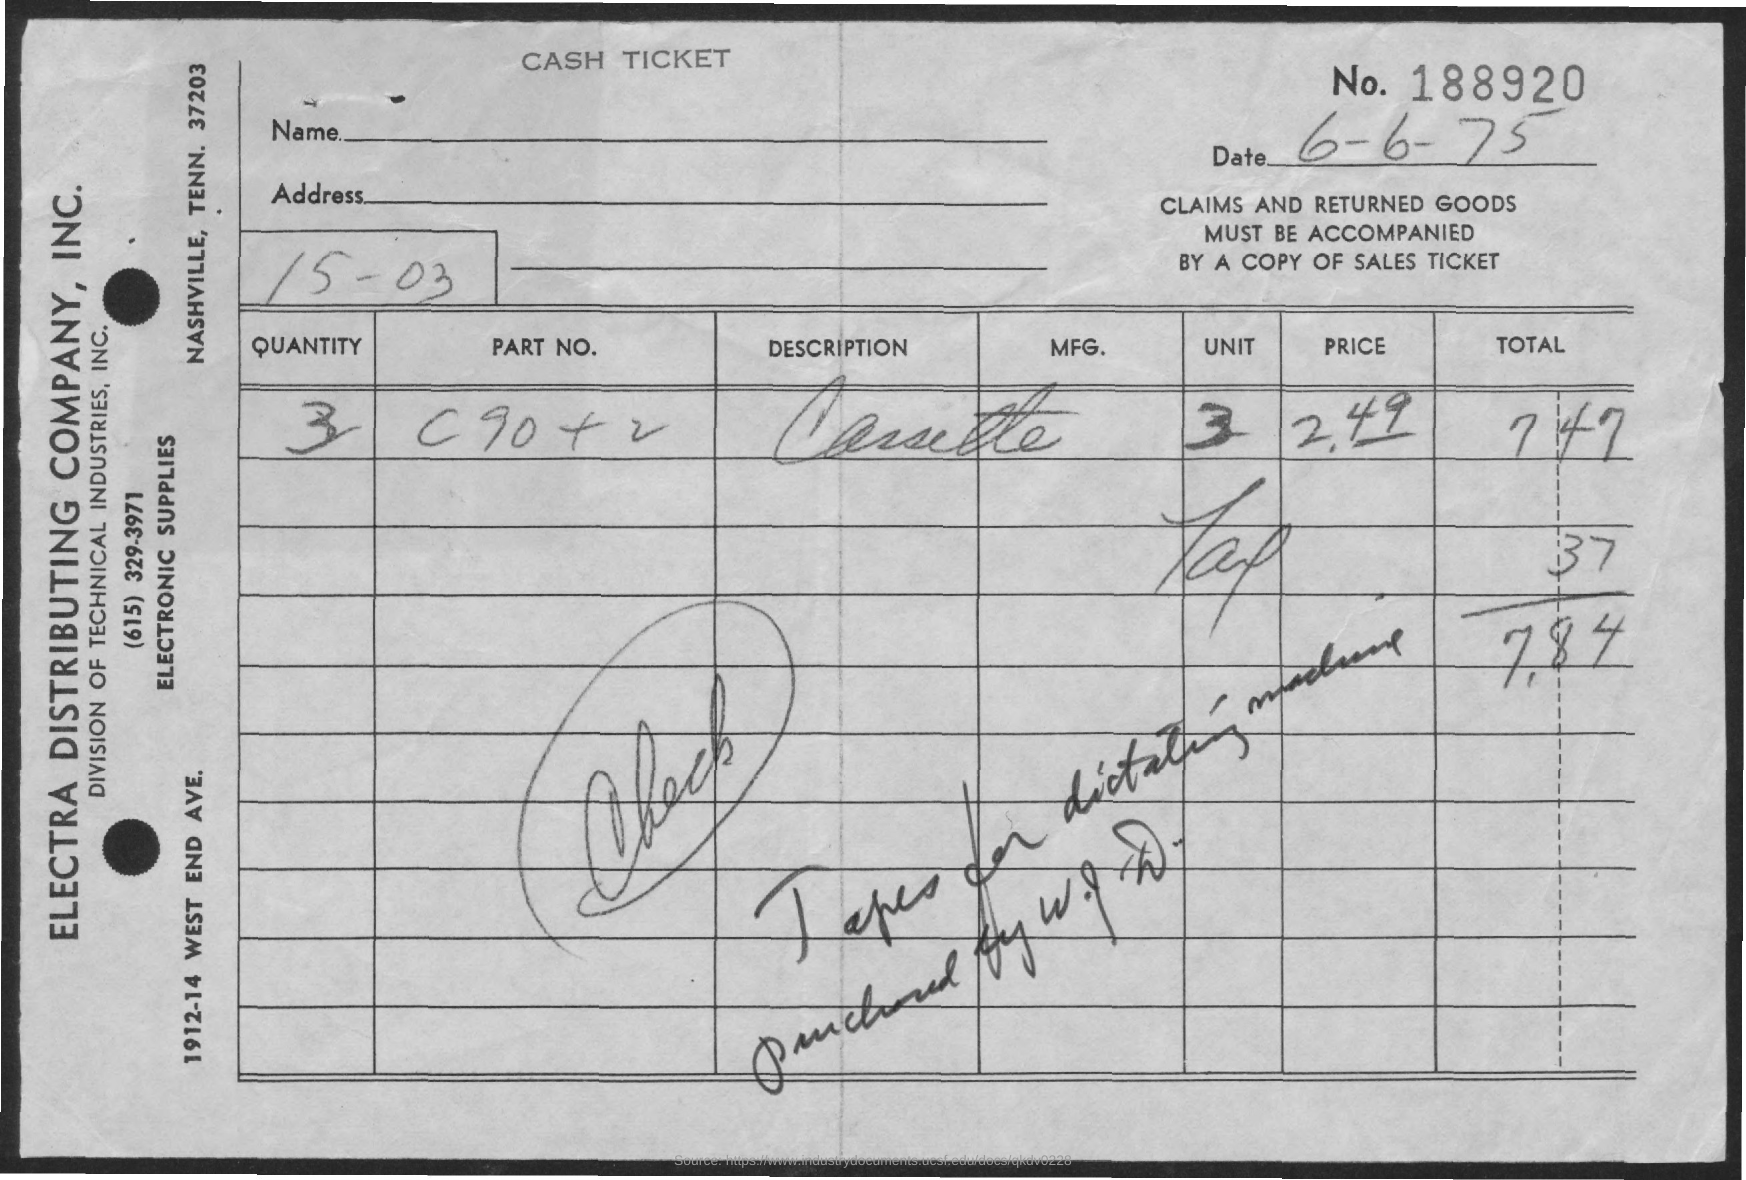Point out several critical features in this image. The price is 2.49. The quantity is 3 and... The total amount is 7.84. The tax is 0.37. The document indicates that the date is June 6th, 1975, as written. 